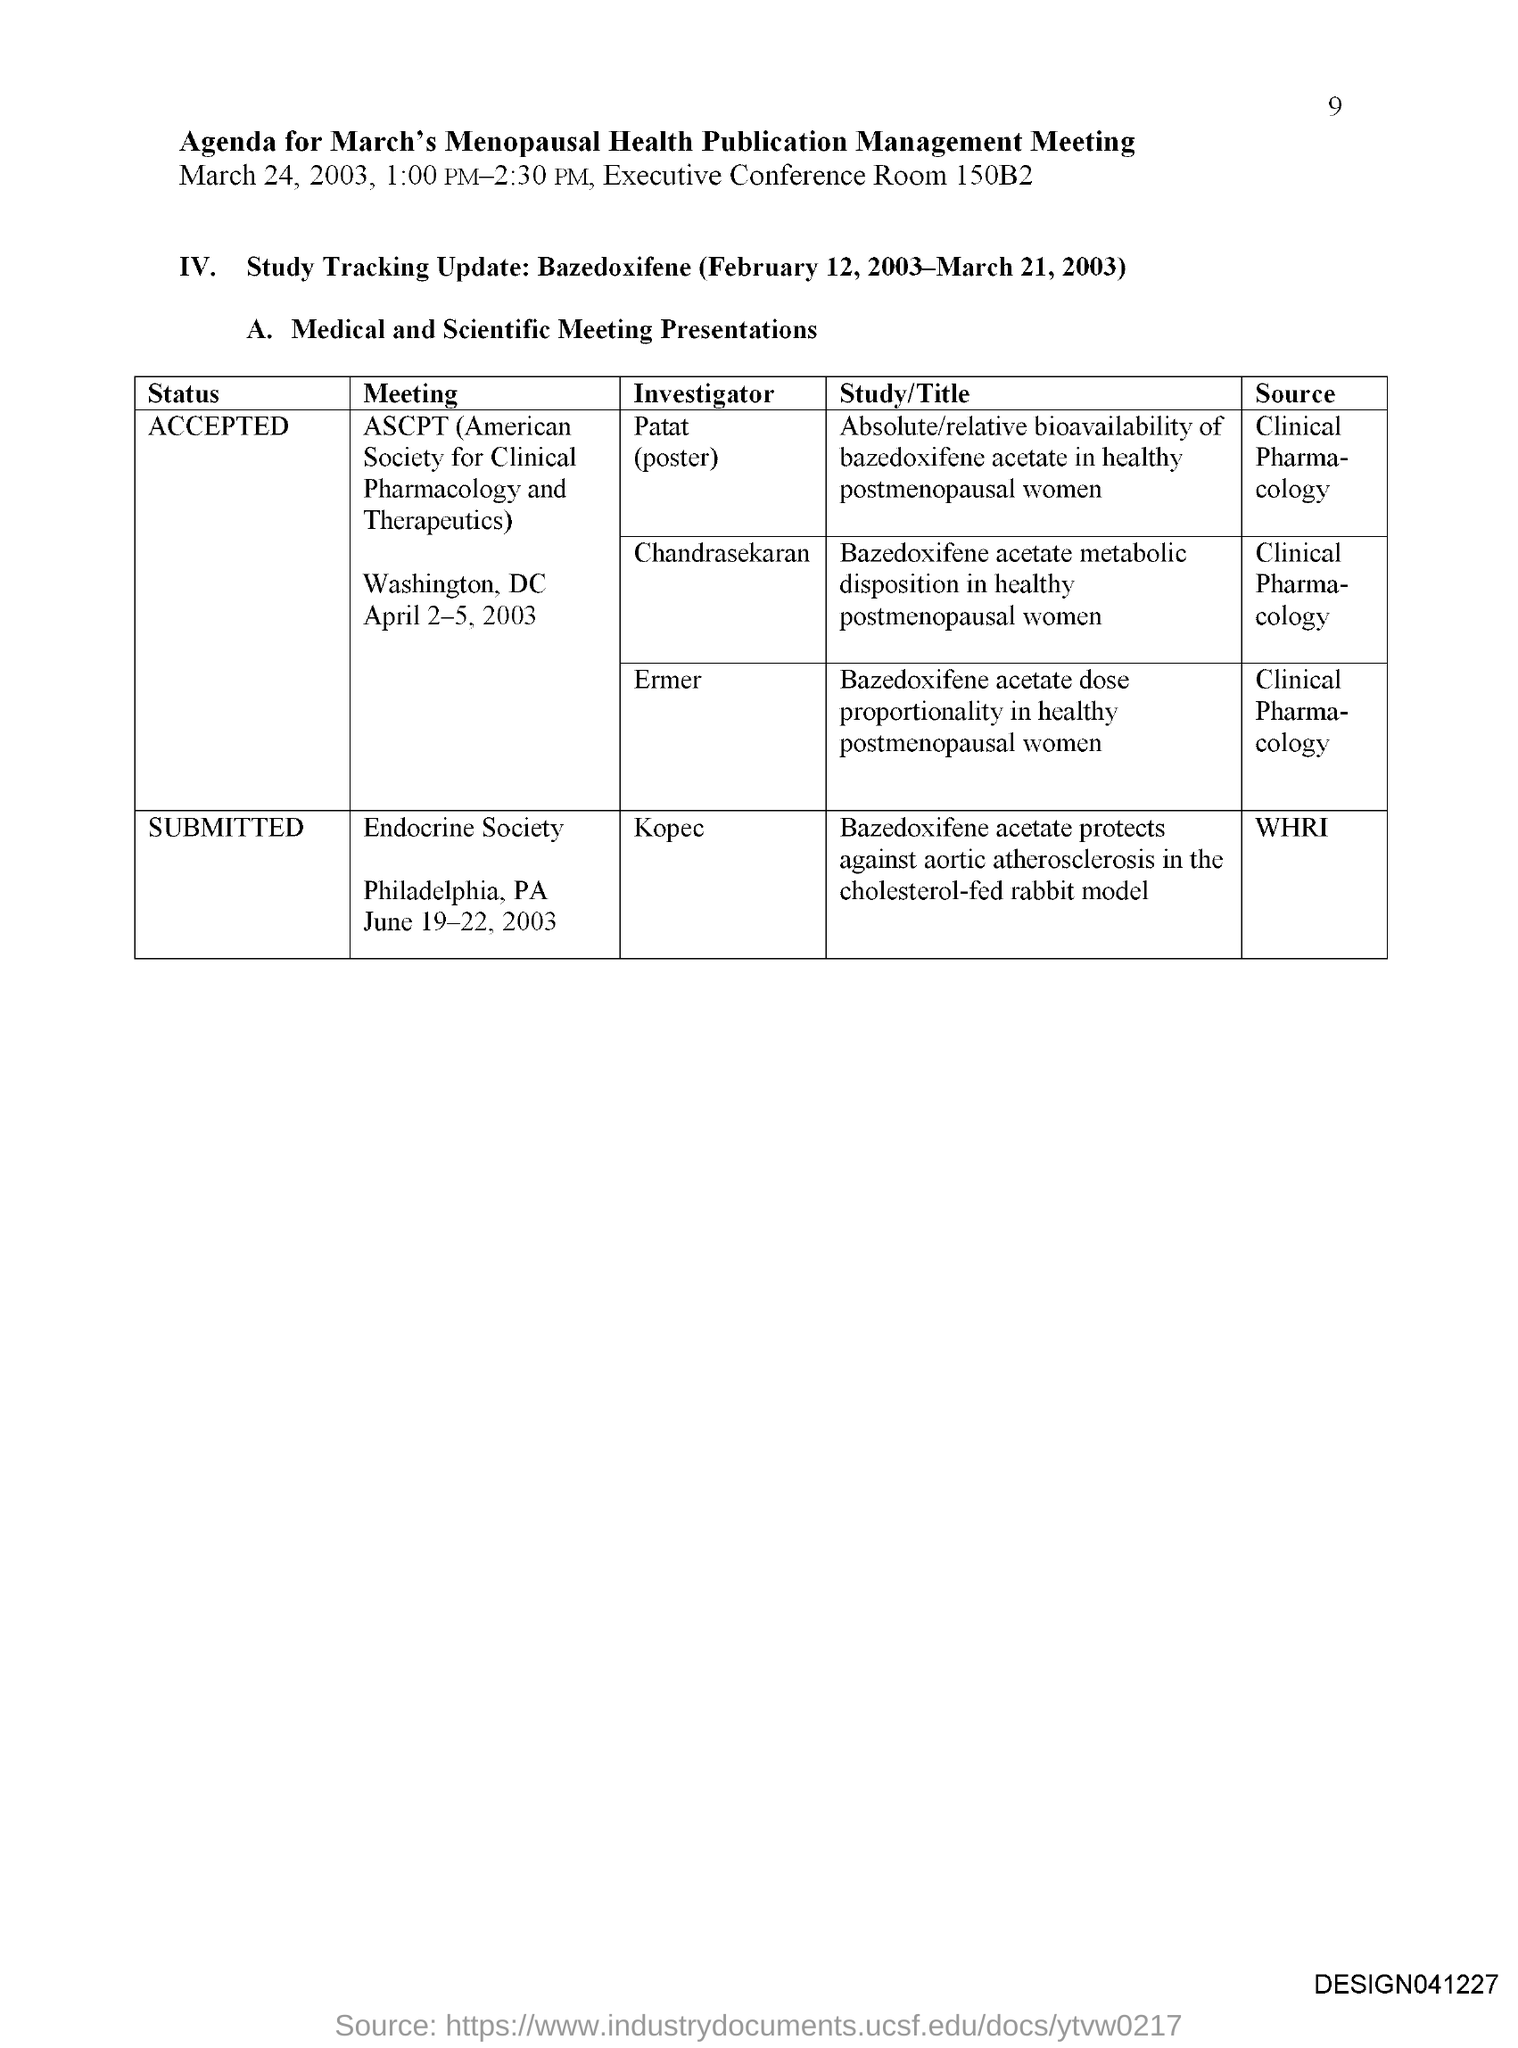Highlight a few significant elements in this photo. The status of the meeting "Endocrine Society" has been submitted. The conference room number is 150B2. The meeting has been accepted. The American Society for Clinical Pharmacology and Therapeutics (ASCPT) is an organization dedicated to advancing the science and practice of clinical pharmacology and therapeutics. I have just informed you that the page number is 9. 